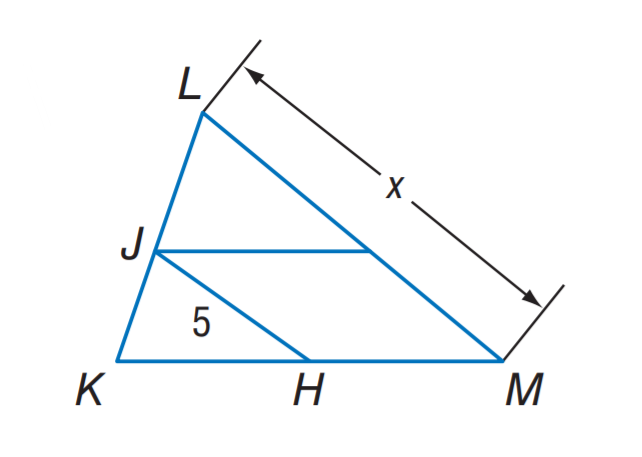Answer the mathemtical geometry problem and directly provide the correct option letter.
Question: J H is a midsegment of \triangle K L M. Find x.
Choices: A: 5 B: 10 C: 15 D: 20 B 